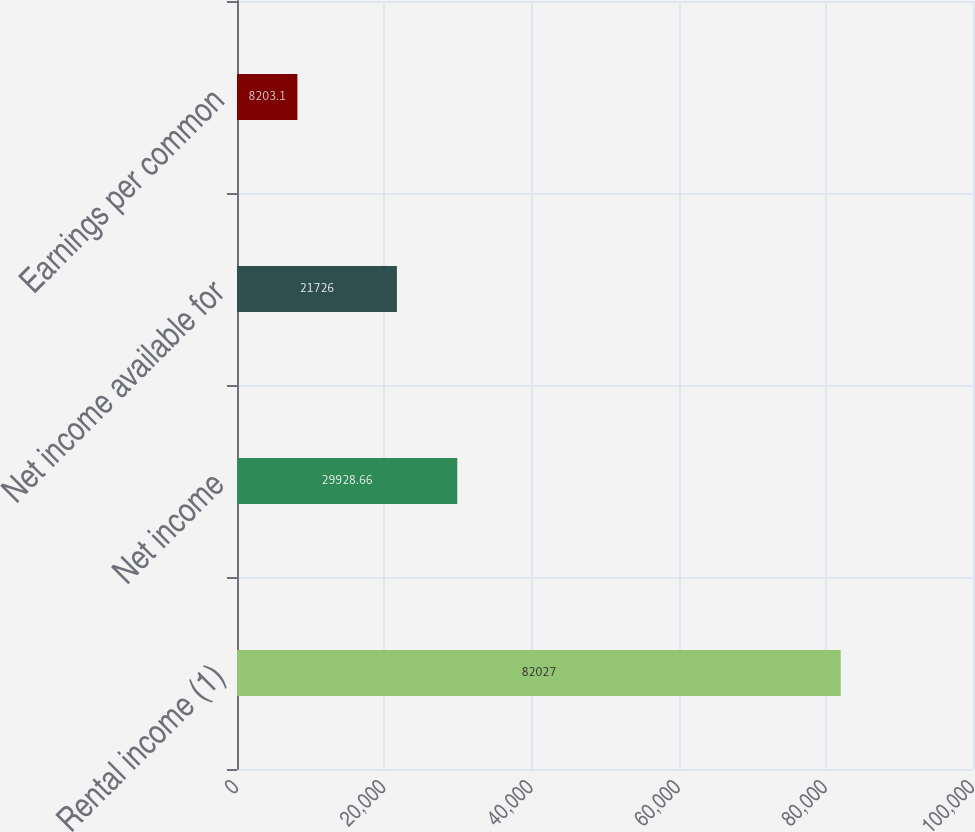Convert chart to OTSL. <chart><loc_0><loc_0><loc_500><loc_500><bar_chart><fcel>Rental income (1)<fcel>Net income<fcel>Net income available for<fcel>Earnings per common<nl><fcel>82027<fcel>29928.7<fcel>21726<fcel>8203.1<nl></chart> 